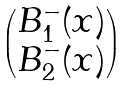Convert formula to latex. <formula><loc_0><loc_0><loc_500><loc_500>\begin{pmatrix} B _ { 1 } ^ { - } ( x ) \\ B _ { 2 } ^ { - } ( x ) \end{pmatrix}</formula> 